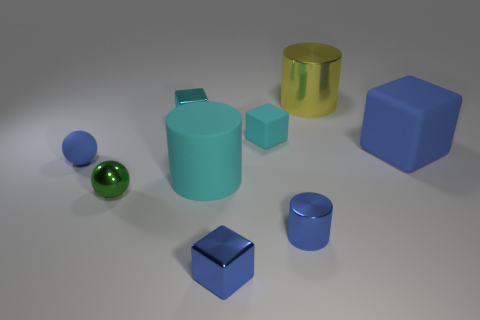There is a large cylinder behind the tiny rubber thing behind the large matte cube; what is it made of?
Provide a short and direct response. Metal. There is a small blue object behind the tiny green ball; is it the same shape as the blue rubber object to the right of the metal ball?
Your response must be concise. No. Is the number of big cyan objects behind the small blue rubber thing the same as the number of big cyan cylinders?
Offer a very short reply. No. There is a metal thing behind the small cyan shiny object; is there a small cyan rubber cube behind it?
Provide a succinct answer. No. Are there any other things that have the same color as the big matte cylinder?
Offer a terse response. Yes. Is the cyan object that is in front of the blue rubber cube made of the same material as the tiny cylinder?
Keep it short and to the point. No. Are there an equal number of yellow cylinders that are behind the cyan cylinder and cyan rubber things behind the blue rubber cube?
Offer a very short reply. Yes. There is a cyan rubber object that is left of the tiny rubber object that is behind the blue matte ball; what is its size?
Keep it short and to the point. Large. What is the material of the tiny thing that is right of the small blue block and behind the green sphere?
Your response must be concise. Rubber. What number of other objects are the same size as the cyan cylinder?
Provide a succinct answer. 2. 